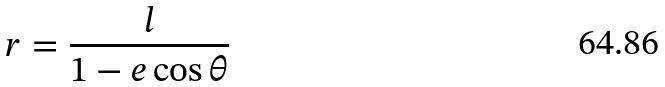<formula> <loc_0><loc_0><loc_500><loc_500>r = \frac { l } { 1 - e \cos \theta }</formula> 